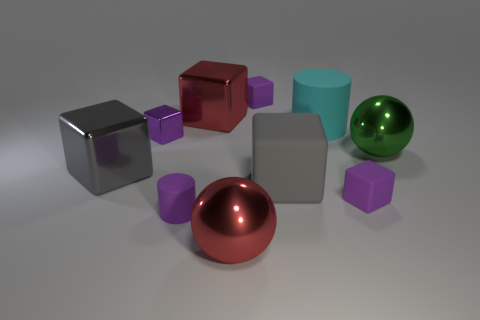The object that is the same color as the large rubber cube is what size?
Ensure brevity in your answer.  Large. Are there an equal number of big gray metallic objects behind the gray shiny cube and tiny purple metal objects that are to the right of the cyan rubber cylinder?
Provide a succinct answer. Yes. What number of other matte objects are the same shape as the cyan rubber object?
Ensure brevity in your answer.  1. Is there a big red block made of the same material as the large green ball?
Your answer should be very brief. Yes. What number of tiny blue rubber balls are there?
Provide a short and direct response. 0. What number of cylinders are either green objects or gray things?
Keep it short and to the point. 0. There is a cylinder that is the same size as the gray metal cube; what color is it?
Keep it short and to the point. Cyan. How many blocks are both on the right side of the tiny cylinder and left of the big cyan rubber thing?
Keep it short and to the point. 3. What is the material of the purple cylinder?
Your answer should be compact. Rubber. How many objects are either rubber cylinders or big rubber cylinders?
Keep it short and to the point. 2. 